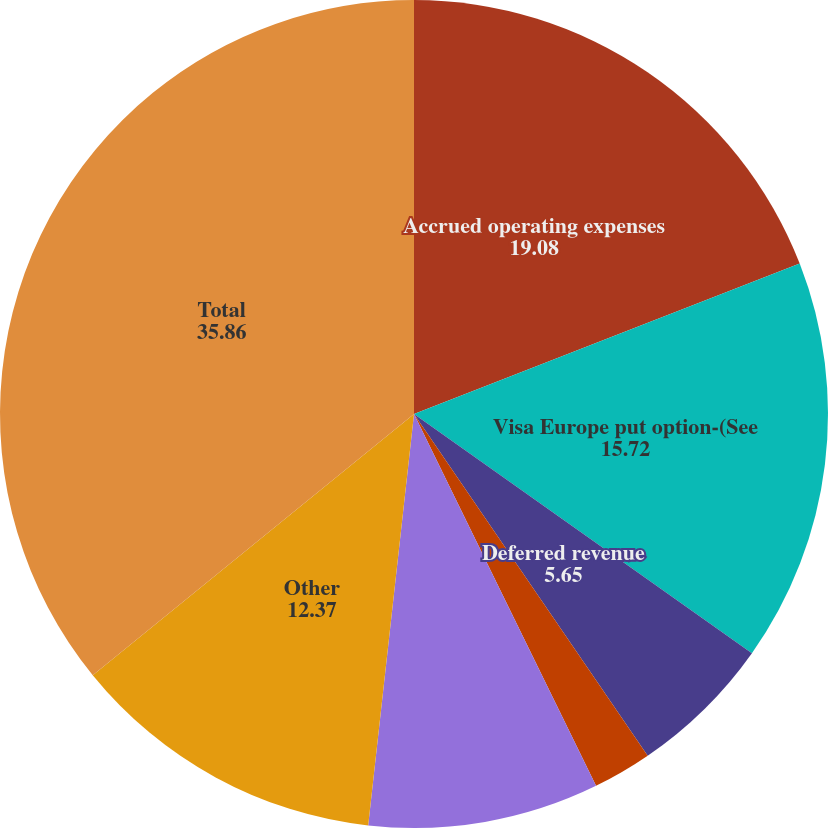Convert chart to OTSL. <chart><loc_0><loc_0><loc_500><loc_500><pie_chart><fcel>Accrued operating expenses<fcel>Visa Europe put option-(See<fcel>Deferred revenue<fcel>Accrued marketing and product<fcel>Accrued income taxes-(See Note<fcel>Other<fcel>Total<nl><fcel>19.08%<fcel>15.72%<fcel>5.65%<fcel>2.3%<fcel>9.01%<fcel>12.37%<fcel>35.86%<nl></chart> 